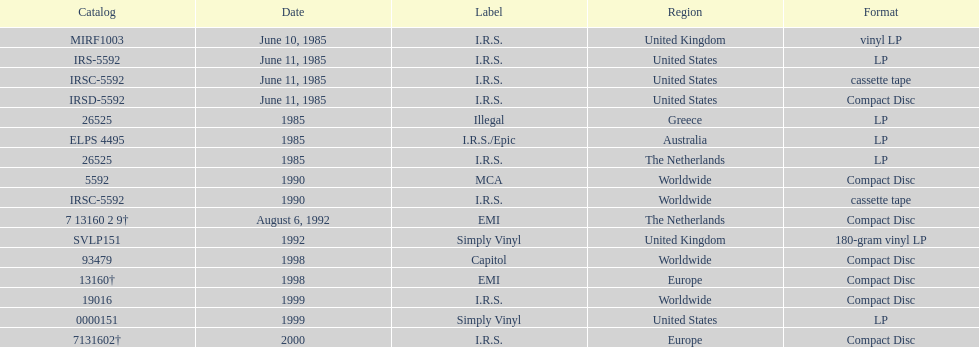Name another region for the 1985 release other than greece. Australia. 